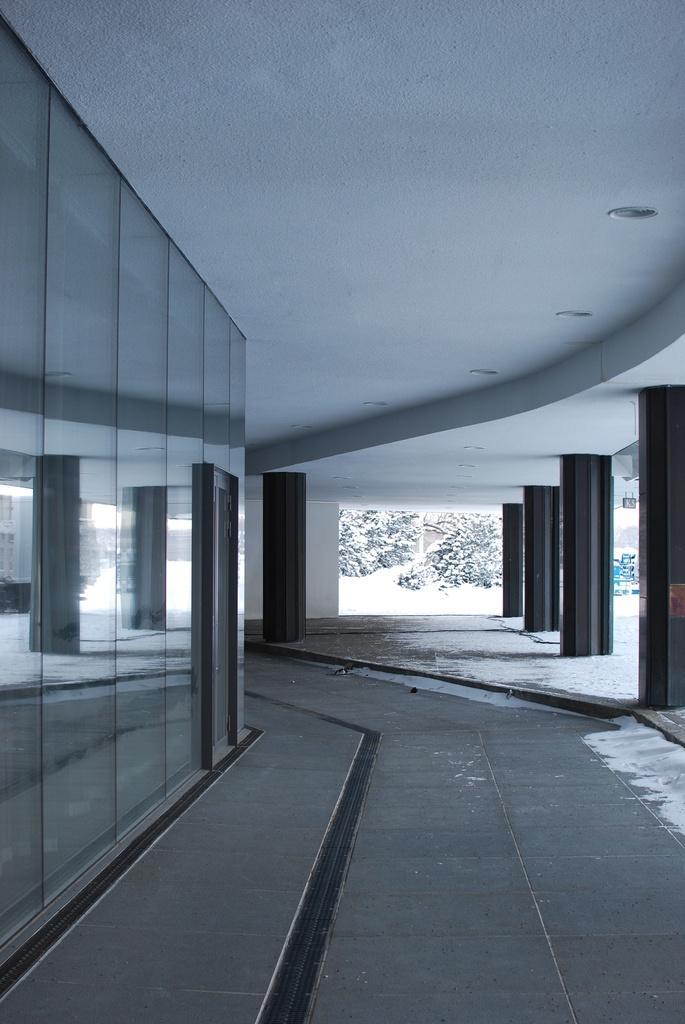Describe this image in one or two sentences. In this image we can see a corridor, trees, floor and mirrors. 